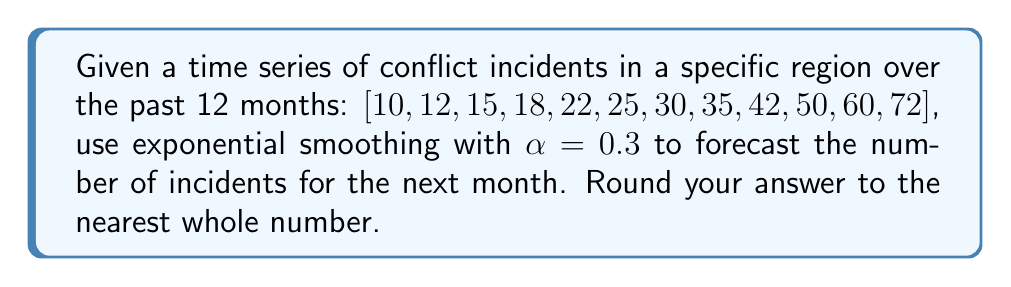Provide a solution to this math problem. To solve this problem, we'll use the exponential smoothing formula:

$$F_{t+1} = \alpha Y_t + (1-\alpha)F_t$$

Where:
$F_{t+1}$ is the forecast for the next period
$\alpha$ is the smoothing factor (0.3 in this case)
$Y_t$ is the actual value for the current period
$F_t$ is the forecast for the current period

Steps:
1) We start with the last actual value, 72, as our initial forecast.

2) Apply the formula:
   $$F_{13} = 0.3 \times 72 + (1-0.3) \times 72$$
   
3) Simplify:
   $$F_{13} = 21.6 + 0.7 \times 72$$
   $$F_{13} = 21.6 + 50.4$$
   $$F_{13} = 72$$

4) Round to the nearest whole number: 72

This method predicts that the conflict incidents will continue at the same level as the previous month, which is reasonable given the exponential growth trend in the data. However, it's important to note that exponential smoothing tends to lag behind when there's a strong trend, as seen in this case.
Answer: 72 